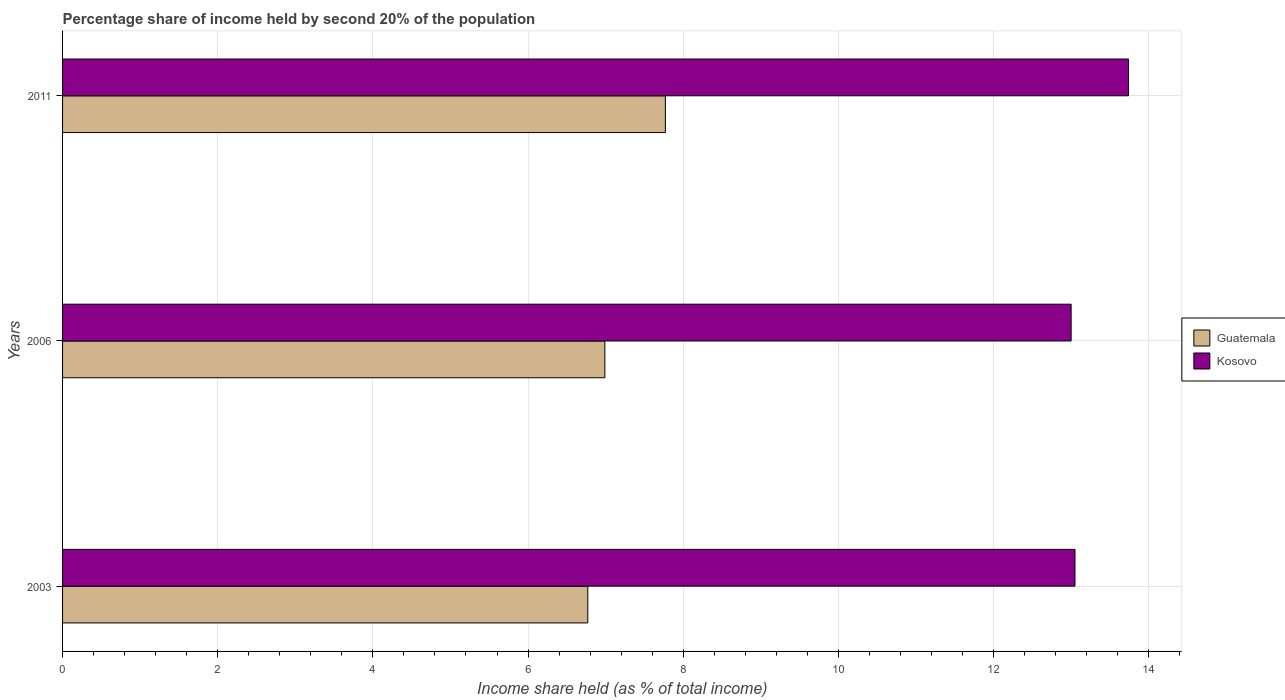How many groups of bars are there?
Your answer should be very brief. 3. How many bars are there on the 2nd tick from the top?
Offer a terse response. 2. What is the label of the 2nd group of bars from the top?
Your response must be concise. 2006. What is the share of income held by second 20% of the population in Kosovo in 2003?
Provide a succinct answer. 13.05. Across all years, what is the maximum share of income held by second 20% of the population in Kosovo?
Your answer should be very brief. 13.74. In which year was the share of income held by second 20% of the population in Guatemala maximum?
Your answer should be very brief. 2011. What is the total share of income held by second 20% of the population in Guatemala in the graph?
Your answer should be very brief. 21.53. What is the difference between the share of income held by second 20% of the population in Guatemala in 2006 and the share of income held by second 20% of the population in Kosovo in 2003?
Provide a succinct answer. -6.06. What is the average share of income held by second 20% of the population in Guatemala per year?
Ensure brevity in your answer.  7.18. In the year 2006, what is the difference between the share of income held by second 20% of the population in Guatemala and share of income held by second 20% of the population in Kosovo?
Keep it short and to the point. -6.01. What is the ratio of the share of income held by second 20% of the population in Guatemala in 2006 to that in 2011?
Provide a succinct answer. 0.9. Is the difference between the share of income held by second 20% of the population in Guatemala in 2003 and 2006 greater than the difference between the share of income held by second 20% of the population in Kosovo in 2003 and 2006?
Provide a succinct answer. No. What is the difference between the highest and the second highest share of income held by second 20% of the population in Kosovo?
Give a very brief answer. 0.69. What is the difference between the highest and the lowest share of income held by second 20% of the population in Kosovo?
Keep it short and to the point. 0.74. Is the sum of the share of income held by second 20% of the population in Guatemala in 2006 and 2011 greater than the maximum share of income held by second 20% of the population in Kosovo across all years?
Give a very brief answer. Yes. What does the 2nd bar from the top in 2003 represents?
Offer a very short reply. Guatemala. What does the 1st bar from the bottom in 2006 represents?
Offer a terse response. Guatemala. How many bars are there?
Your answer should be very brief. 6. Are all the bars in the graph horizontal?
Provide a short and direct response. Yes. How many years are there in the graph?
Provide a succinct answer. 3. Does the graph contain any zero values?
Keep it short and to the point. No. Does the graph contain grids?
Your answer should be very brief. Yes. Where does the legend appear in the graph?
Offer a very short reply. Center right. How many legend labels are there?
Provide a succinct answer. 2. How are the legend labels stacked?
Your answer should be very brief. Vertical. What is the title of the graph?
Provide a succinct answer. Percentage share of income held by second 20% of the population. What is the label or title of the X-axis?
Keep it short and to the point. Income share held (as % of total income). What is the Income share held (as % of total income) of Guatemala in 2003?
Provide a short and direct response. 6.77. What is the Income share held (as % of total income) of Kosovo in 2003?
Offer a very short reply. 13.05. What is the Income share held (as % of total income) of Guatemala in 2006?
Make the answer very short. 6.99. What is the Income share held (as % of total income) of Kosovo in 2006?
Ensure brevity in your answer.  13. What is the Income share held (as % of total income) of Guatemala in 2011?
Keep it short and to the point. 7.77. What is the Income share held (as % of total income) in Kosovo in 2011?
Provide a short and direct response. 13.74. Across all years, what is the maximum Income share held (as % of total income) of Guatemala?
Your answer should be compact. 7.77. Across all years, what is the maximum Income share held (as % of total income) in Kosovo?
Ensure brevity in your answer.  13.74. Across all years, what is the minimum Income share held (as % of total income) in Guatemala?
Your answer should be very brief. 6.77. What is the total Income share held (as % of total income) in Guatemala in the graph?
Your answer should be compact. 21.53. What is the total Income share held (as % of total income) in Kosovo in the graph?
Your answer should be compact. 39.79. What is the difference between the Income share held (as % of total income) of Guatemala in 2003 and that in 2006?
Your response must be concise. -0.22. What is the difference between the Income share held (as % of total income) of Guatemala in 2003 and that in 2011?
Ensure brevity in your answer.  -1. What is the difference between the Income share held (as % of total income) in Kosovo in 2003 and that in 2011?
Make the answer very short. -0.69. What is the difference between the Income share held (as % of total income) of Guatemala in 2006 and that in 2011?
Ensure brevity in your answer.  -0.78. What is the difference between the Income share held (as % of total income) in Kosovo in 2006 and that in 2011?
Your answer should be very brief. -0.74. What is the difference between the Income share held (as % of total income) of Guatemala in 2003 and the Income share held (as % of total income) of Kosovo in 2006?
Provide a succinct answer. -6.23. What is the difference between the Income share held (as % of total income) of Guatemala in 2003 and the Income share held (as % of total income) of Kosovo in 2011?
Ensure brevity in your answer.  -6.97. What is the difference between the Income share held (as % of total income) of Guatemala in 2006 and the Income share held (as % of total income) of Kosovo in 2011?
Offer a terse response. -6.75. What is the average Income share held (as % of total income) in Guatemala per year?
Offer a very short reply. 7.18. What is the average Income share held (as % of total income) in Kosovo per year?
Your answer should be very brief. 13.26. In the year 2003, what is the difference between the Income share held (as % of total income) in Guatemala and Income share held (as % of total income) in Kosovo?
Make the answer very short. -6.28. In the year 2006, what is the difference between the Income share held (as % of total income) in Guatemala and Income share held (as % of total income) in Kosovo?
Make the answer very short. -6.01. In the year 2011, what is the difference between the Income share held (as % of total income) of Guatemala and Income share held (as % of total income) of Kosovo?
Give a very brief answer. -5.97. What is the ratio of the Income share held (as % of total income) in Guatemala in 2003 to that in 2006?
Give a very brief answer. 0.97. What is the ratio of the Income share held (as % of total income) of Guatemala in 2003 to that in 2011?
Offer a terse response. 0.87. What is the ratio of the Income share held (as % of total income) of Kosovo in 2003 to that in 2011?
Make the answer very short. 0.95. What is the ratio of the Income share held (as % of total income) in Guatemala in 2006 to that in 2011?
Provide a short and direct response. 0.9. What is the ratio of the Income share held (as % of total income) in Kosovo in 2006 to that in 2011?
Your answer should be very brief. 0.95. What is the difference between the highest and the second highest Income share held (as % of total income) in Guatemala?
Offer a terse response. 0.78. What is the difference between the highest and the second highest Income share held (as % of total income) in Kosovo?
Your answer should be compact. 0.69. What is the difference between the highest and the lowest Income share held (as % of total income) in Kosovo?
Your answer should be compact. 0.74. 